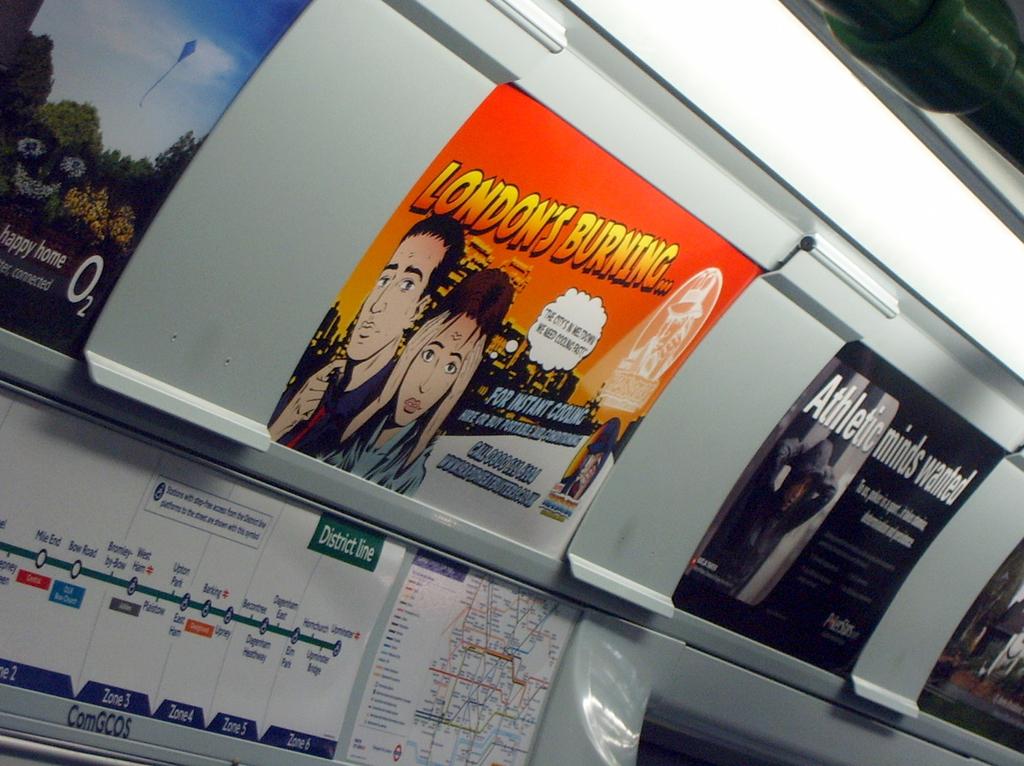What city is burning?
Your answer should be very brief. London. What does the sign on the right want?
Your response must be concise. Athletic minds. 